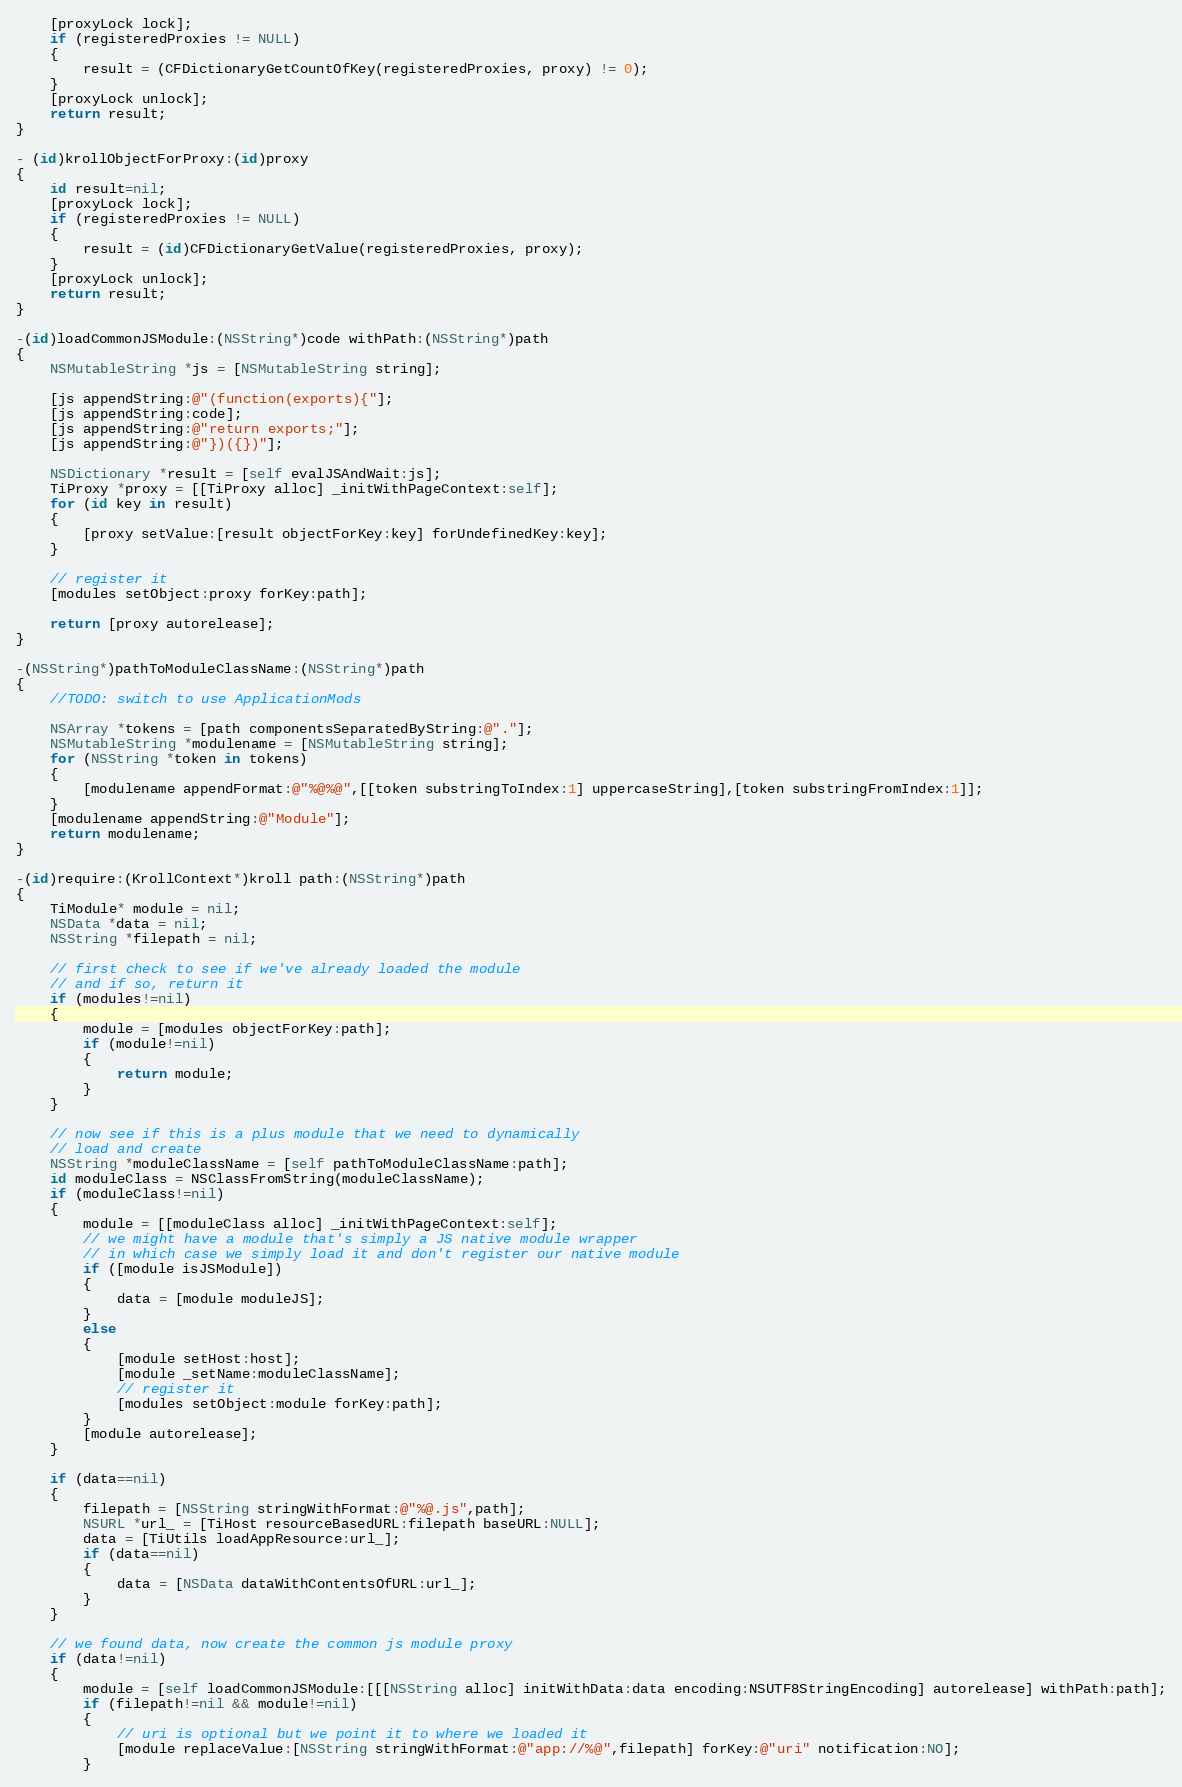<code> <loc_0><loc_0><loc_500><loc_500><_ObjectiveC_>	[proxyLock lock];
	if (registeredProxies != NULL)
	{
		result = (CFDictionaryGetCountOfKey(registeredProxies, proxy) != 0);
	}
	[proxyLock unlock];
	return result;
}

- (id)krollObjectForProxy:(id)proxy
{
	id result=nil;
	[proxyLock lock];
	if (registeredProxies != NULL)
	{
		result = (id)CFDictionaryGetValue(registeredProxies, proxy);
	}
	[proxyLock unlock];
	return result;
}

-(id)loadCommonJSModule:(NSString*)code withPath:(NSString*)path
{
	NSMutableString *js = [NSMutableString string];
	
	[js appendString:@"(function(exports){"];
	[js appendString:code];
	[js appendString:@"return exports;"];
	[js appendString:@"})({})"];
	
	NSDictionary *result = [self evalJSAndWait:js];
	TiProxy *proxy = [[TiProxy alloc] _initWithPageContext:self];
	for (id key in result)
	{
		[proxy setValue:[result objectForKey:key] forUndefinedKey:key];
	}
	
	// register it
	[modules setObject:proxy forKey:path];
	
	return [proxy autorelease];
}

-(NSString*)pathToModuleClassName:(NSString*)path
{
	//TODO: switch to use ApplicationMods
	
	NSArray *tokens = [path componentsSeparatedByString:@"."];
	NSMutableString *modulename = [NSMutableString string];
	for (NSString *token in tokens)
	{
		[modulename appendFormat:@"%@%@",[[token substringToIndex:1] uppercaseString],[token substringFromIndex:1]];
	}
	[modulename appendString:@"Module"];
	return modulename;
}

-(id)require:(KrollContext*)kroll path:(NSString*)path
{
	TiModule* module = nil;
	NSData *data = nil;
	NSString *filepath = nil;
	
	// first check to see if we've already loaded the module
	// and if so, return it
	if (modules!=nil)
	{
		module = [modules objectForKey:path];
		if (module!=nil)
		{
			return module;
		}
	}
	
	// now see if this is a plus module that we need to dynamically
	// load and create
	NSString *moduleClassName = [self pathToModuleClassName:path];
	id moduleClass = NSClassFromString(moduleClassName);
	if (moduleClass!=nil)
	{
		module = [[moduleClass alloc] _initWithPageContext:self];
		// we might have a module that's simply a JS native module wrapper
		// in which case we simply load it and don't register our native module
		if ([module isJSModule])
		{
			data = [module moduleJS];
		}
		else
		{
			[module setHost:host];
			[module _setName:moduleClassName];
			// register it
			[modules setObject:module forKey:path];
		}
		[module autorelease];
	}
	
	if (data==nil)
	{
		filepath = [NSString stringWithFormat:@"%@.js",path];
		NSURL *url_ = [TiHost resourceBasedURL:filepath baseURL:NULL];
		data = [TiUtils loadAppResource:url_];
		if (data==nil)
		{
			data = [NSData dataWithContentsOfURL:url_];
		}
	}

	// we found data, now create the common js module proxy
	if (data!=nil)
	{
		module = [self loadCommonJSModule:[[[NSString alloc] initWithData:data encoding:NSUTF8StringEncoding] autorelease] withPath:path];
		if (filepath!=nil && module!=nil)
		{
			// uri is optional but we point it to where we loaded it
			[module replaceValue:[NSString stringWithFormat:@"app://%@",filepath] forKey:@"uri" notification:NO];
		}</code> 